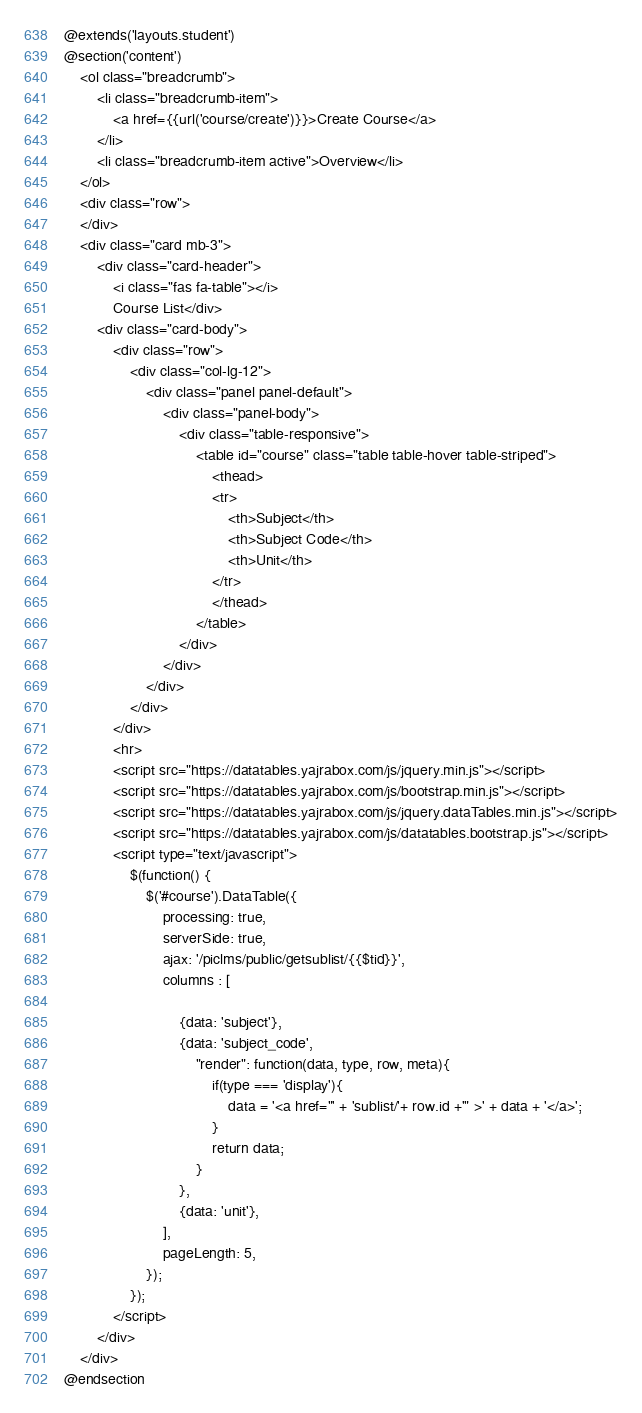Convert code to text. <code><loc_0><loc_0><loc_500><loc_500><_PHP_>@extends('layouts.student')
@section('content')
    <ol class="breadcrumb">
        <li class="breadcrumb-item">
            <a href={{url('course/create')}}>Create Course</a>
        </li>
        <li class="breadcrumb-item active">Overview</li>
    </ol>
    <div class="row">
    </div>
    <div class="card mb-3">
        <div class="card-header">
            <i class="fas fa-table"></i>
            Course List</div>
        <div class="card-body">
            <div class="row">
                <div class="col-lg-12">
                    <div class="panel panel-default">
                        <div class="panel-body">
                            <div class="table-responsive">
                                <table id="course" class="table table-hover table-striped">
                                    <thead>
                                    <tr>
                                        <th>Subject</th>
                                        <th>Subject Code</th>
                                        <th>Unit</th>
                                    </tr>
                                    </thead>
                                </table>
                            </div>
                        </div>
                    </div>
                </div>
            </div>
            <hr>
            <script src="https://datatables.yajrabox.com/js/jquery.min.js"></script>
            <script src="https://datatables.yajrabox.com/js/bootstrap.min.js"></script>
            <script src="https://datatables.yajrabox.com/js/jquery.dataTables.min.js"></script>
            <script src="https://datatables.yajrabox.com/js/datatables.bootstrap.js"></script>
            <script type="text/javascript">
                $(function() {
                    $('#course').DataTable({
                        processing: true,
                        serverSide: true,
                        ajax: '/piclms/public/getsublist/{{$tid}}',
                        columns : [

                            {data: 'subject'},
                            {data: 'subject_code',
                                "render": function(data, type, row, meta){
                                    if(type === 'display'){
                                        data = '<a href="' + 'sublist/'+ row.id +'" >' + data + '</a>';
                                    }
                                    return data;
                                }
                            },
                            {data: 'unit'},
                        ],
                        pageLength: 5,
                    });
                });
            </script>
        </div>
    </div>
@endsection</code> 